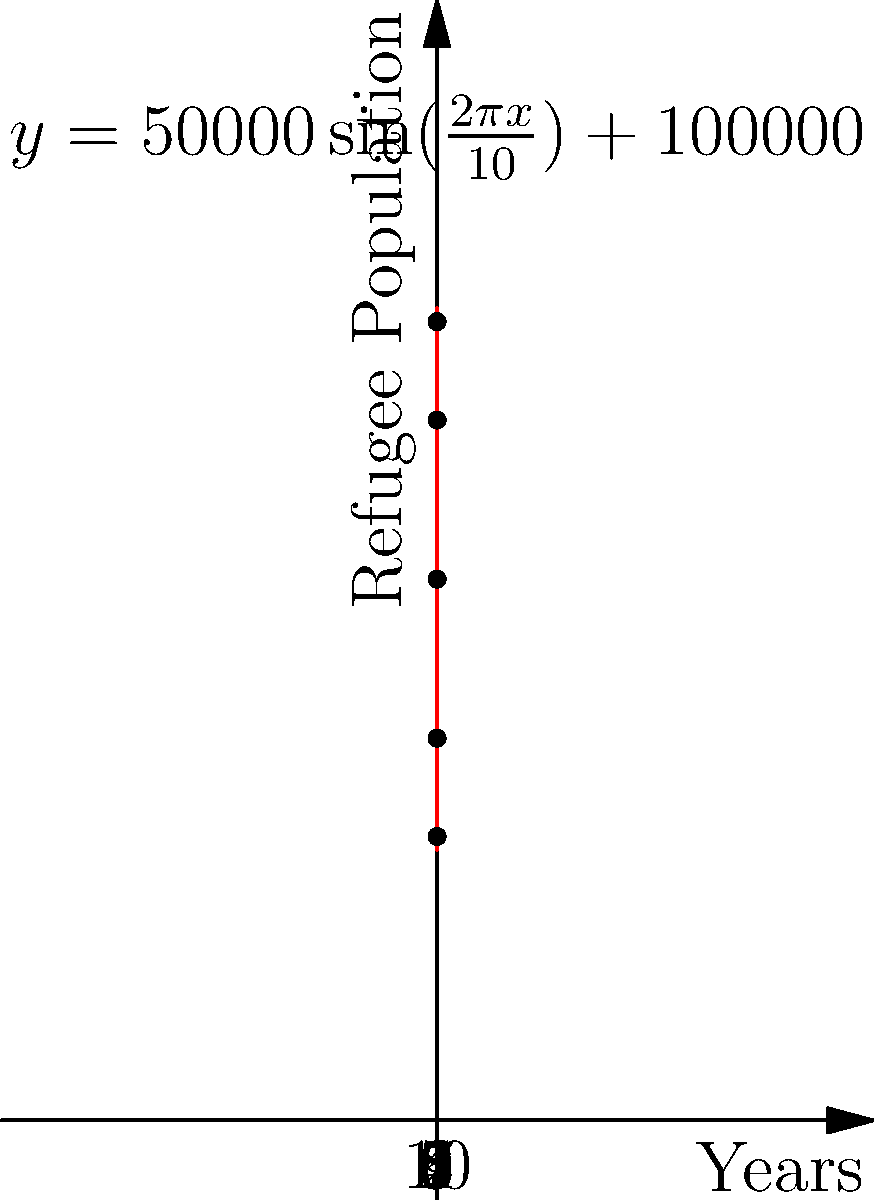Given the sinusoidal function $y = 50000\sin(\frac{2\pi x}{10}) + 100000$ representing refugee population fluctuations over a 10-year period, where $x$ represents years and $y$ represents the number of refugees, at what year does the refugee population reach its maximum? How might this peak in refugee numbers correlate with significant global events? To find the year when the refugee population reaches its maximum:

1) The general form of a sinusoidal function is $y = A\sin(B(x-C)) + D$, where:
   $A$ is the amplitude (half the distance between max and min)
   $B$ is $\frac{2\pi}{P}$, where $P$ is the period
   $C$ is the phase shift
   $D$ is the vertical shift (midline)

2) In our function $y = 50000\sin(\frac{2\pi x}{10}) + 100000$:
   $A = 50000$
   $B = \frac{2\pi}{10}$
   $C = 0$
   $D = 100000$

3) The sine function reaches its maximum when its argument is $\frac{\pi}{2} + 2\pi n$, where $n$ is any integer.

4) So, we need to solve: $\frac{2\pi x}{10} = \frac{\pi}{2} + 2\pi n$

5) Simplifying: $x = \frac{5}{2} + 10n$

6) The first maximum within our 10-year period occurs when $n=0$, so $x = 2.5$ years.

This peak at 2.5 years could correlate with the aftermath of a major global event (e.g., conflict, natural disaster) that occurred around the start of the period, allowing time for the impact to fully manifest in refugee numbers. The cyclical nature of the function might reflect recurring patterns in global conflicts or climate-related displacements.
Answer: 2.5 years 